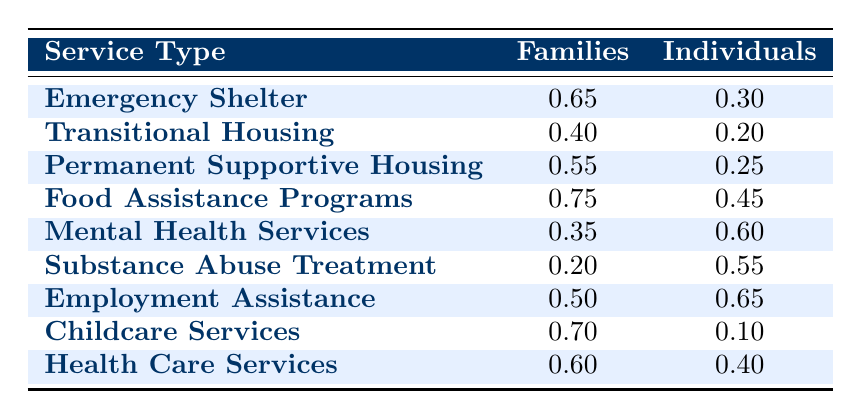What percentage of families utilize Emergency Shelters? According to the table, the families' utilization of Emergency Shelters is listed as 0.65. This represents 65% of families accessing this service.
Answer: 65% What is the utilization rate of individuals for Food Assistance Programs? The table shows that individuals' utilization of Food Assistance Programs is 0.45, which means 45% of individuals access this service.
Answer: 45% Which service has the highest percentage of utilization among families? The table illustrates that Food Assistance Programs have the highest utilization rate among families at 0.75 (75%), which is greater than any other service listed.
Answer: Food Assistance Programs Is the utilization of Mental Health Services higher for families than for individuals? In the table, families utilize Mental Health Services at a rate of 0.35 while individuals utilize it at 0.60. Since 0.35 is less than 0.60, the answer is no.
Answer: No What is the difference in utilization rates between individuals and families for Transitional Housing? The utilization rate for families is 0.40 and for individuals is 0.20. The difference can be calculated as 0.40 - 0.20 = 0.20, meaning families utilize this service more by 20%.
Answer: 0.20 Calculate the average utilization rate for families across all services listed. To find the average for families, sum the utilization rates: 0.65 + 0.40 + 0.55 + 0.75 + 0.35 + 0.20 + 0.50 + 0.70 + 0.60 = 4.30. There are 9 services, so the average is 4.30 / 9 ≈ 0.478 or 47.8%.
Answer: 0.478 (47.8%) Which service shows the largest discrepancy in utilization between families and individuals? By comparing the differences for each service: Emergency Shelter (0.35), Transitional Housing (0.20), Permanent Supportive Housing (0.30), Food Assistance Programs (0.30), Mental Health Services (0.25), Substance Abuse Treatment (0.35), Employment Assistance (0.15), Childcare Services (0.60), and Health Care Services (0.20). The largest discrepancy is seen in Childcare Services at 0.60.
Answer: Childcare Services Do more families or individuals utilize Employment Assistance services? The table indicates that families have a utilization rate of 0.50 and individuals have a rate of 0.65. Since 0.65 is greater than 0.50, it shows that more individuals utilize this service.
Answer: Individuals What percentage of families utilize Substance Abuse Treatment? The table states that families' utilization of Substance Abuse Treatment is 0.20, equating to 20% of families accessing this service.
Answer: 20% 